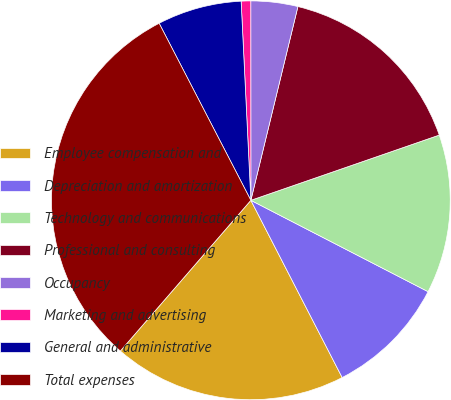Convert chart. <chart><loc_0><loc_0><loc_500><loc_500><pie_chart><fcel>Employee compensation and<fcel>Depreciation and amortization<fcel>Technology and communications<fcel>Professional and consulting<fcel>Occupancy<fcel>Marketing and advertising<fcel>General and administrative<fcel>Total expenses<nl><fcel>18.93%<fcel>9.85%<fcel>12.88%<fcel>15.9%<fcel>3.8%<fcel>0.77%<fcel>6.83%<fcel>31.03%<nl></chart> 